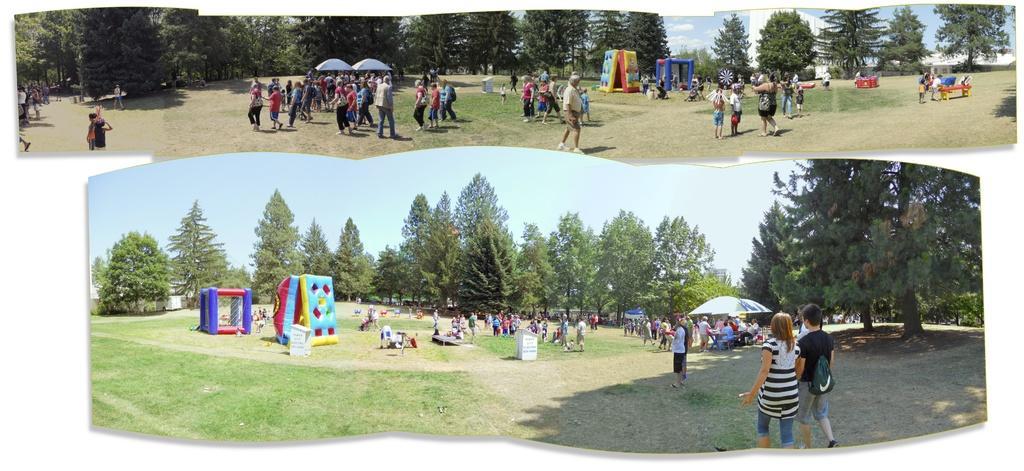Could you give a brief overview of what you see in this image? In this image I can see the collage picture and I can see group of people, some are standing and some are walking, few tents in white color and I can also see few objects in multi color. Background I can see the trees in green color and the sky is in white and blue color. 